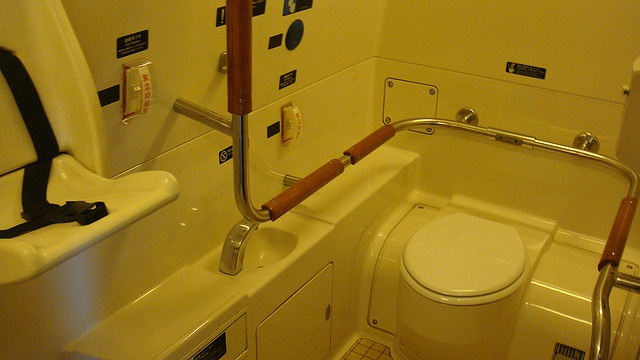Describe the objects in this image and their specific colors. I can see a toilet in olive and tan tones in this image. 